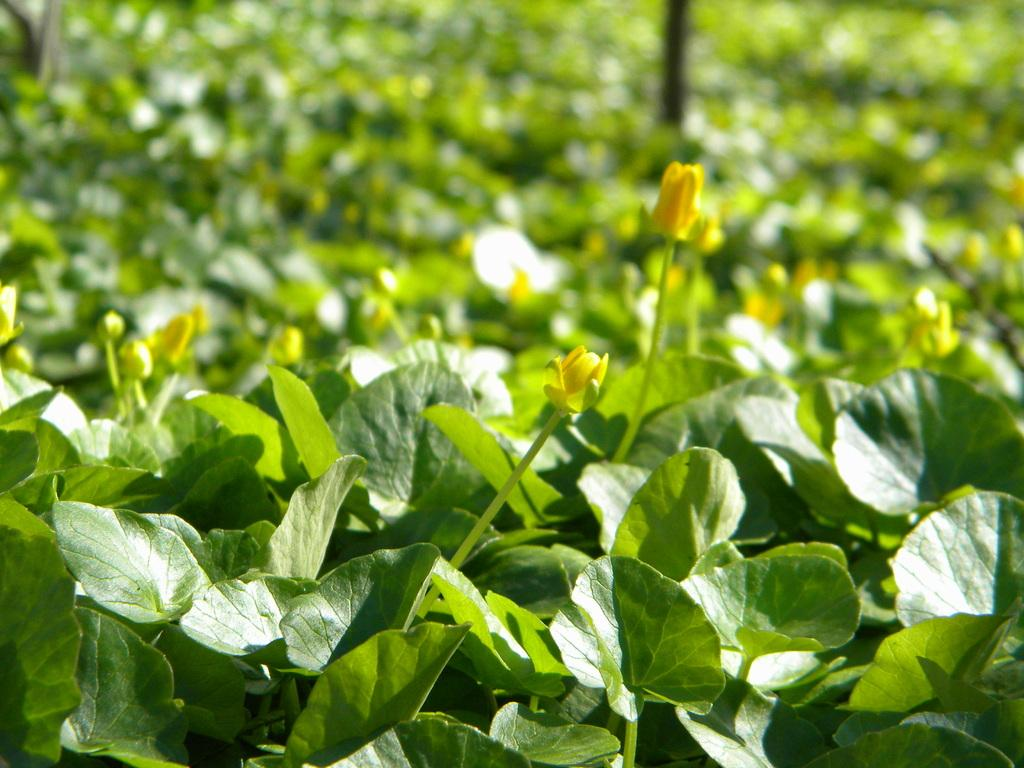What type of living organisms can be seen in the image? Plants can be seen in the image. What specific feature of the plants is visible? The plants have flowers, and the flowers are yellow. Can you describe the plants in the background of the image? There are plants in the background of the image, but their features are not clearly visible due to the blurred background. What else can be seen in the background of the image? There is a pole in the background of the image. What type of fuel is being used by the plants in the image? There is no indication in the image that the plants are using any type of fuel. Can you tell me how many stomachs the plants have in the image? Plants do not have stomachs, as they are not living organisms with digestive systems like animals. 